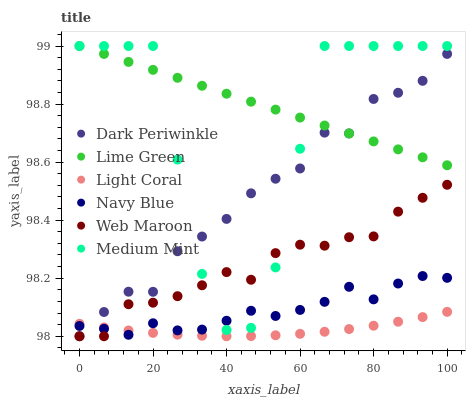Does Light Coral have the minimum area under the curve?
Answer yes or no. Yes. Does Lime Green have the maximum area under the curve?
Answer yes or no. Yes. Does Navy Blue have the minimum area under the curve?
Answer yes or no. No. Does Navy Blue have the maximum area under the curve?
Answer yes or no. No. Is Lime Green the smoothest?
Answer yes or no. Yes. Is Medium Mint the roughest?
Answer yes or no. Yes. Is Navy Blue the smoothest?
Answer yes or no. No. Is Navy Blue the roughest?
Answer yes or no. No. Does Web Maroon have the lowest value?
Answer yes or no. Yes. Does Navy Blue have the lowest value?
Answer yes or no. No. Does Lime Green have the highest value?
Answer yes or no. Yes. Does Navy Blue have the highest value?
Answer yes or no. No. Is Web Maroon less than Lime Green?
Answer yes or no. Yes. Is Lime Green greater than Web Maroon?
Answer yes or no. Yes. Does Lime Green intersect Medium Mint?
Answer yes or no. Yes. Is Lime Green less than Medium Mint?
Answer yes or no. No. Is Lime Green greater than Medium Mint?
Answer yes or no. No. Does Web Maroon intersect Lime Green?
Answer yes or no. No. 